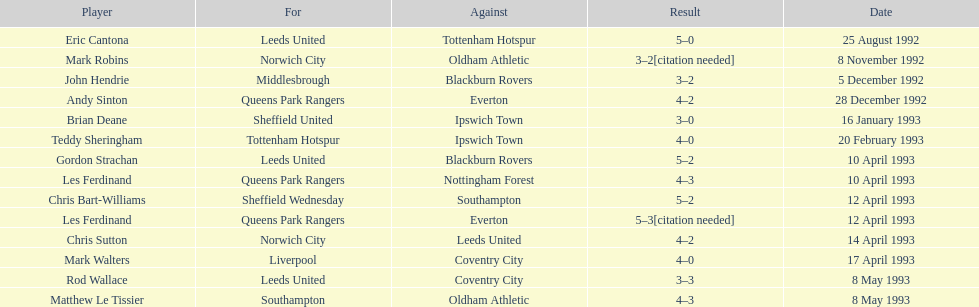Which team does john hendrie represent? Middlesbrough. 